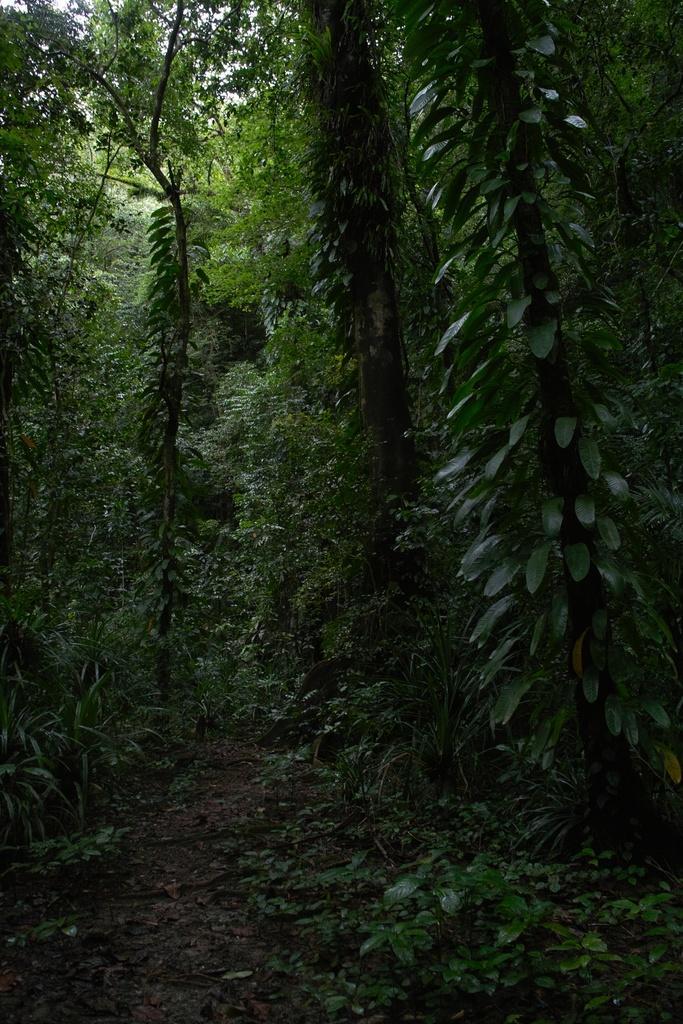Can you describe this image briefly? This picture is clicked outside. In the foreground we can see the plants and the ground. In the background we can see the trees. 